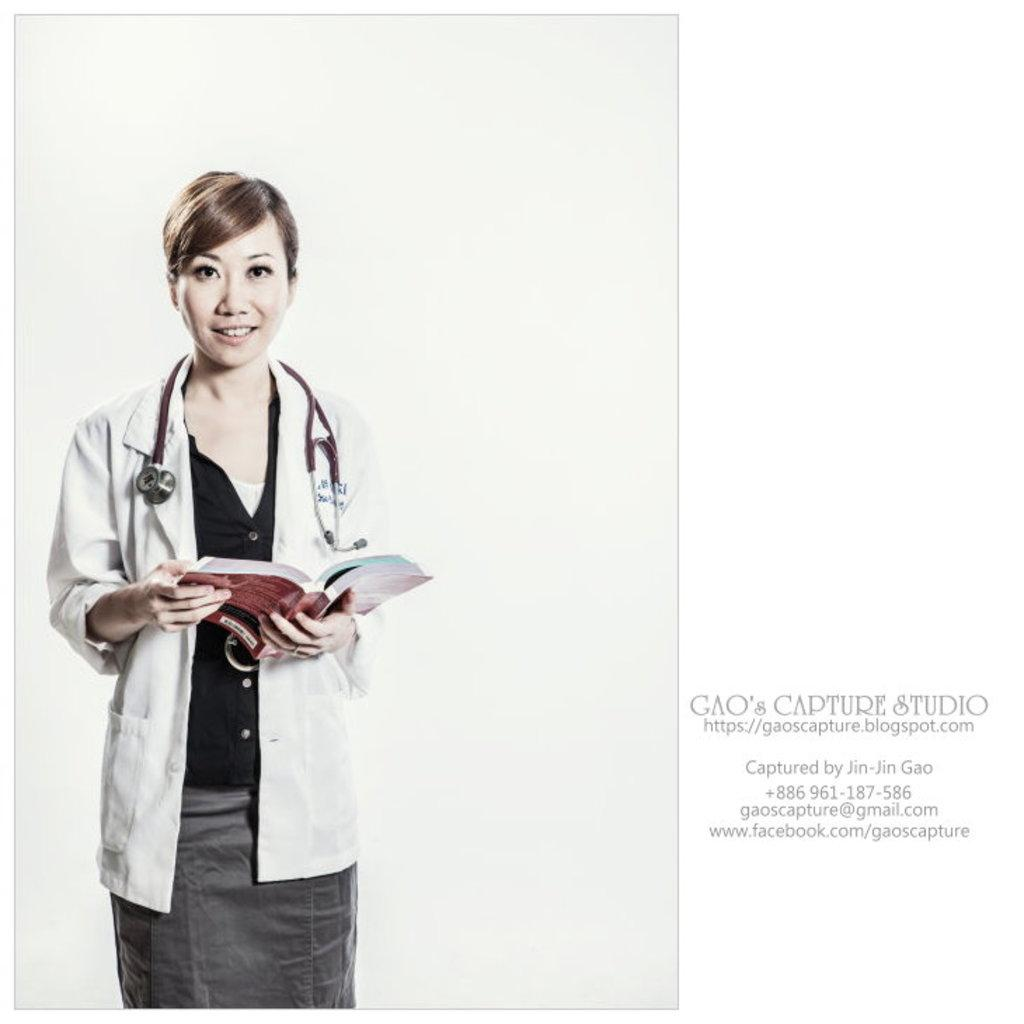Who is the main subject in the image? There is a woman in the image. What is the woman holding in the image? The woman is holding a book. Where is the book located in the image? The book is on the left side of the image. What can be seen on the right side of the image? There is text visible on the right side of the image. What time of day is it in the image, considering the heat and the presence of a laborer? There is no reference to heat or a laborer in the image, so it is not possible to determine the time of day based on these factors. 